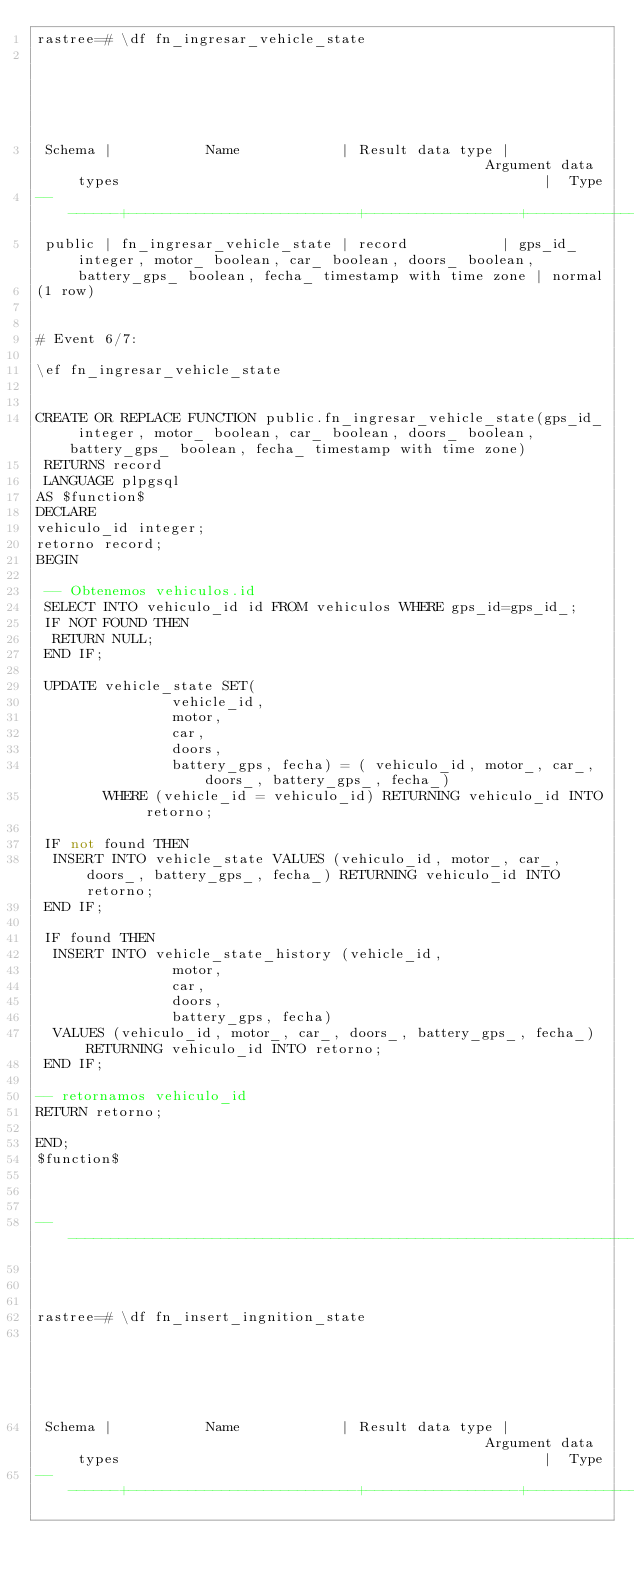<code> <loc_0><loc_0><loc_500><loc_500><_SQL_>rastree=# \df fn_ingresar_vehicle_state
                                                                                   List of functions
 Schema |           Name            | Result data type |                                                 Argument data types                                                  |  Type
--------+---------------------------+------------------+----------------------------------------------------------------------------------------------------------------------+--------
 public | fn_ingresar_vehicle_state | record           | gps_id_ integer, motor_ boolean, car_ boolean, doors_ boolean, battery_gps_ boolean, fecha_ timestamp with time zone | normal
(1 row)


# Event 6/7:

\ef fn_ingresar_vehicle_state


CREATE OR REPLACE FUNCTION public.fn_ingresar_vehicle_state(gps_id_ integer, motor_ boolean, car_ boolean, doors_ boolean, battery_gps_ boolean, fecha_ timestamp with time zone)
 RETURNS record
 LANGUAGE plpgsql
AS $function$
DECLARE
vehiculo_id integer;
retorno record;
BEGIN

 -- Obtenemos vehiculos.id
 SELECT INTO vehiculo_id id FROM vehiculos WHERE gps_id=gps_id_;
 IF NOT FOUND THEN
  RETURN NULL;
 END IF;

 UPDATE vehicle_state SET(
                vehicle_id,
                motor,
                car,
                doors,
                battery_gps, fecha) = ( vehiculo_id, motor_, car_, doors_, battery_gps_, fecha_)
        WHERE (vehicle_id = vehiculo_id) RETURNING vehiculo_id INTO retorno;

 IF not found THEN
  INSERT INTO vehicle_state VALUES (vehiculo_id, motor_, car_, doors_, battery_gps_, fecha_) RETURNING vehiculo_id INTO retorno;
 END IF;

 IF found THEN
  INSERT INTO vehicle_state_history (vehicle_id,
                motor,
                car,
                doors,
                battery_gps, fecha)
  VALUES (vehiculo_id, motor_, car_, doors_, battery_gps_, fecha_) RETURNING vehiculo_id INTO retorno;
 END IF;

-- retornamos vehiculo_id
RETURN retorno;

END;
$function$



-------------------------------------------------------------------------------------------------------------------------------



rastree=# \df fn_insert_ingnition_state
                                                                                   List of functions
 Schema |           Name            | Result data type |                                                 Argument data types                                                  |  Type
--------+---------------------------+------------------+----------------------------------------------------------------------------------------------------------------------+--------</code> 